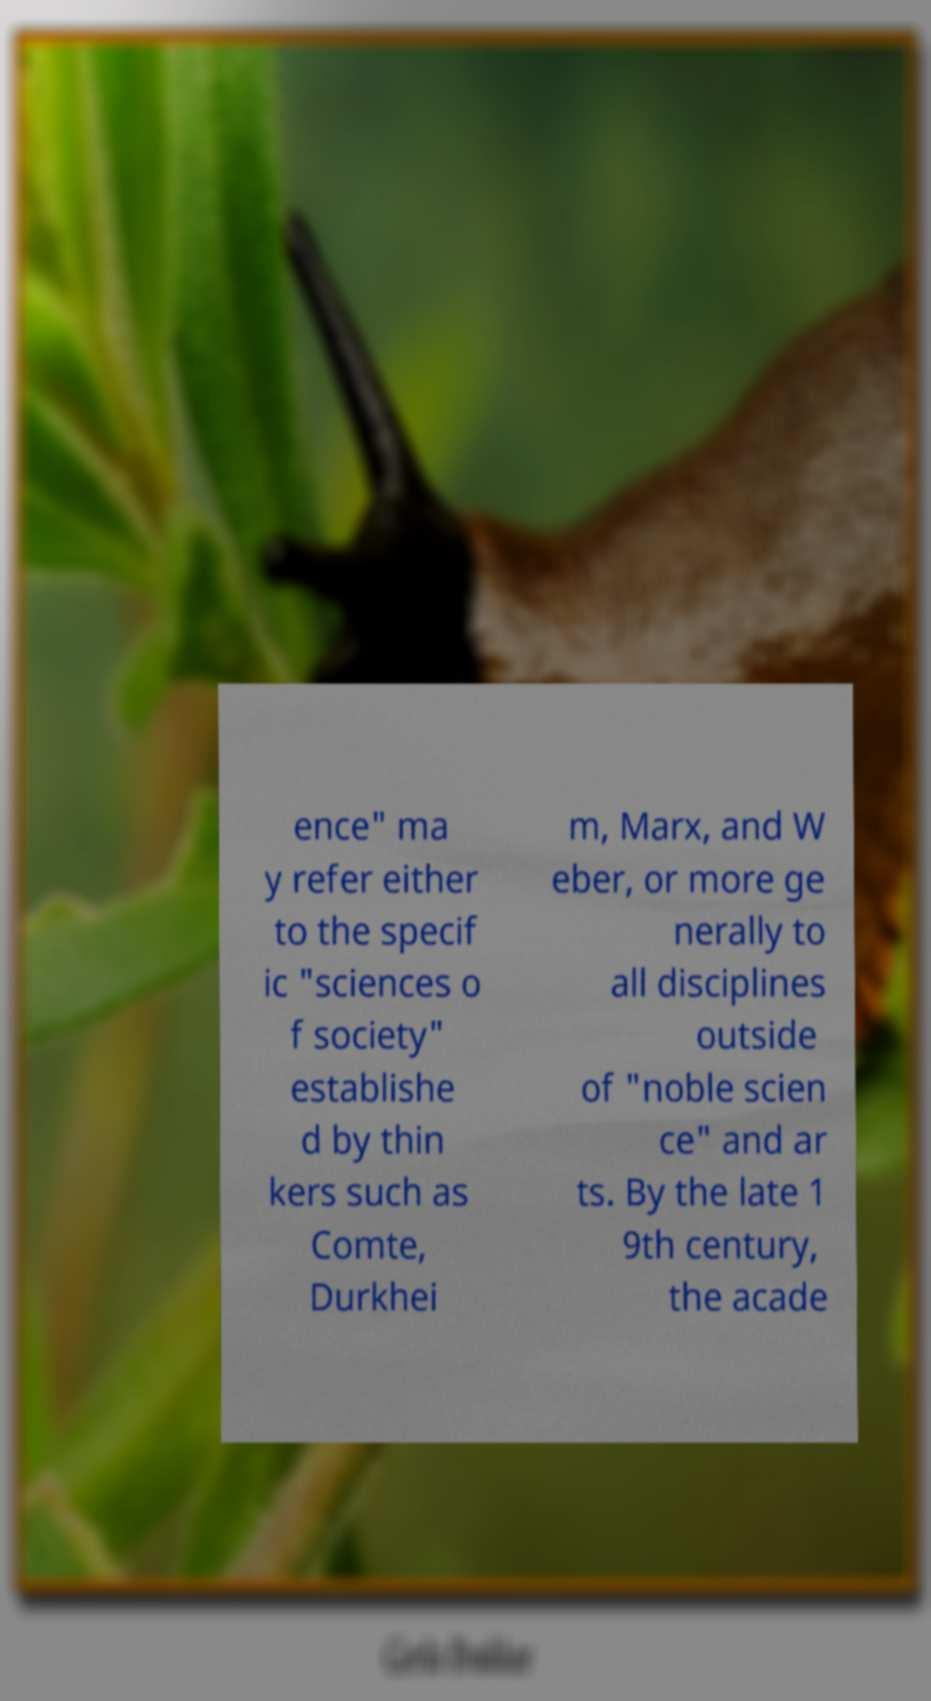Please identify and transcribe the text found in this image. ence" ma y refer either to the specif ic "sciences o f society" establishe d by thin kers such as Comte, Durkhei m, Marx, and W eber, or more ge nerally to all disciplines outside of "noble scien ce" and ar ts. By the late 1 9th century, the acade 